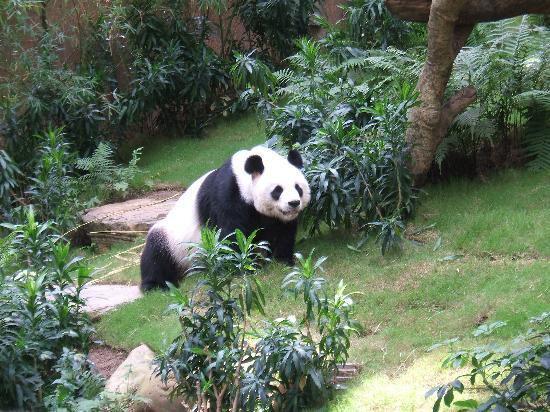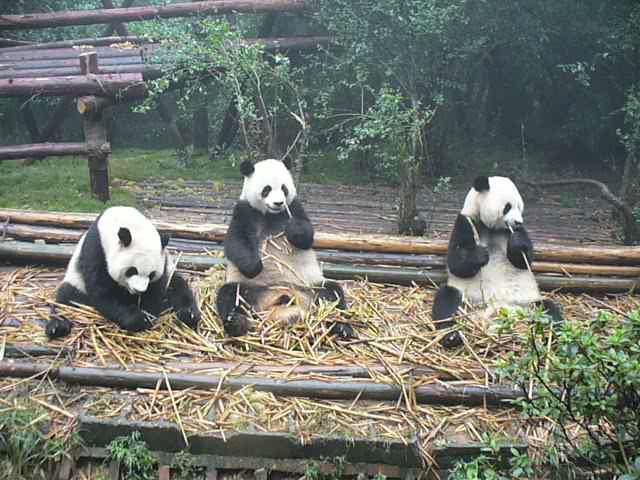The first image is the image on the left, the second image is the image on the right. For the images displayed, is the sentence "There are no more than four panda bears." factually correct? Answer yes or no. Yes. The first image is the image on the left, the second image is the image on the right. Assess this claim about the two images: "No image contains more than three pandas, one image contains a single panda, and a structure made of horizontal wooden poles is pictured in an image.". Correct or not? Answer yes or no. Yes. 